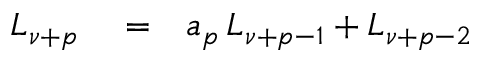<formula> <loc_0><loc_0><loc_500><loc_500>\begin{array} { r l r } { L _ { \nu + p } } & = } & { a _ { p } \, L _ { \nu + p - 1 } + L _ { \nu + p - 2 } } \end{array}</formula> 